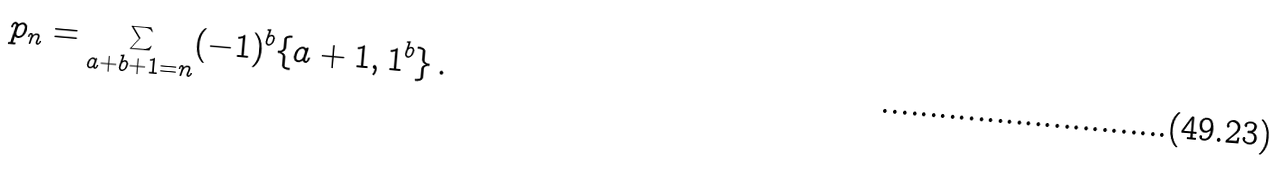<formula> <loc_0><loc_0><loc_500><loc_500>p _ { n } & = \sum _ { a + b + 1 = n } ( - 1 ) ^ { b } \{ a + 1 , 1 ^ { b } \} \, .</formula> 